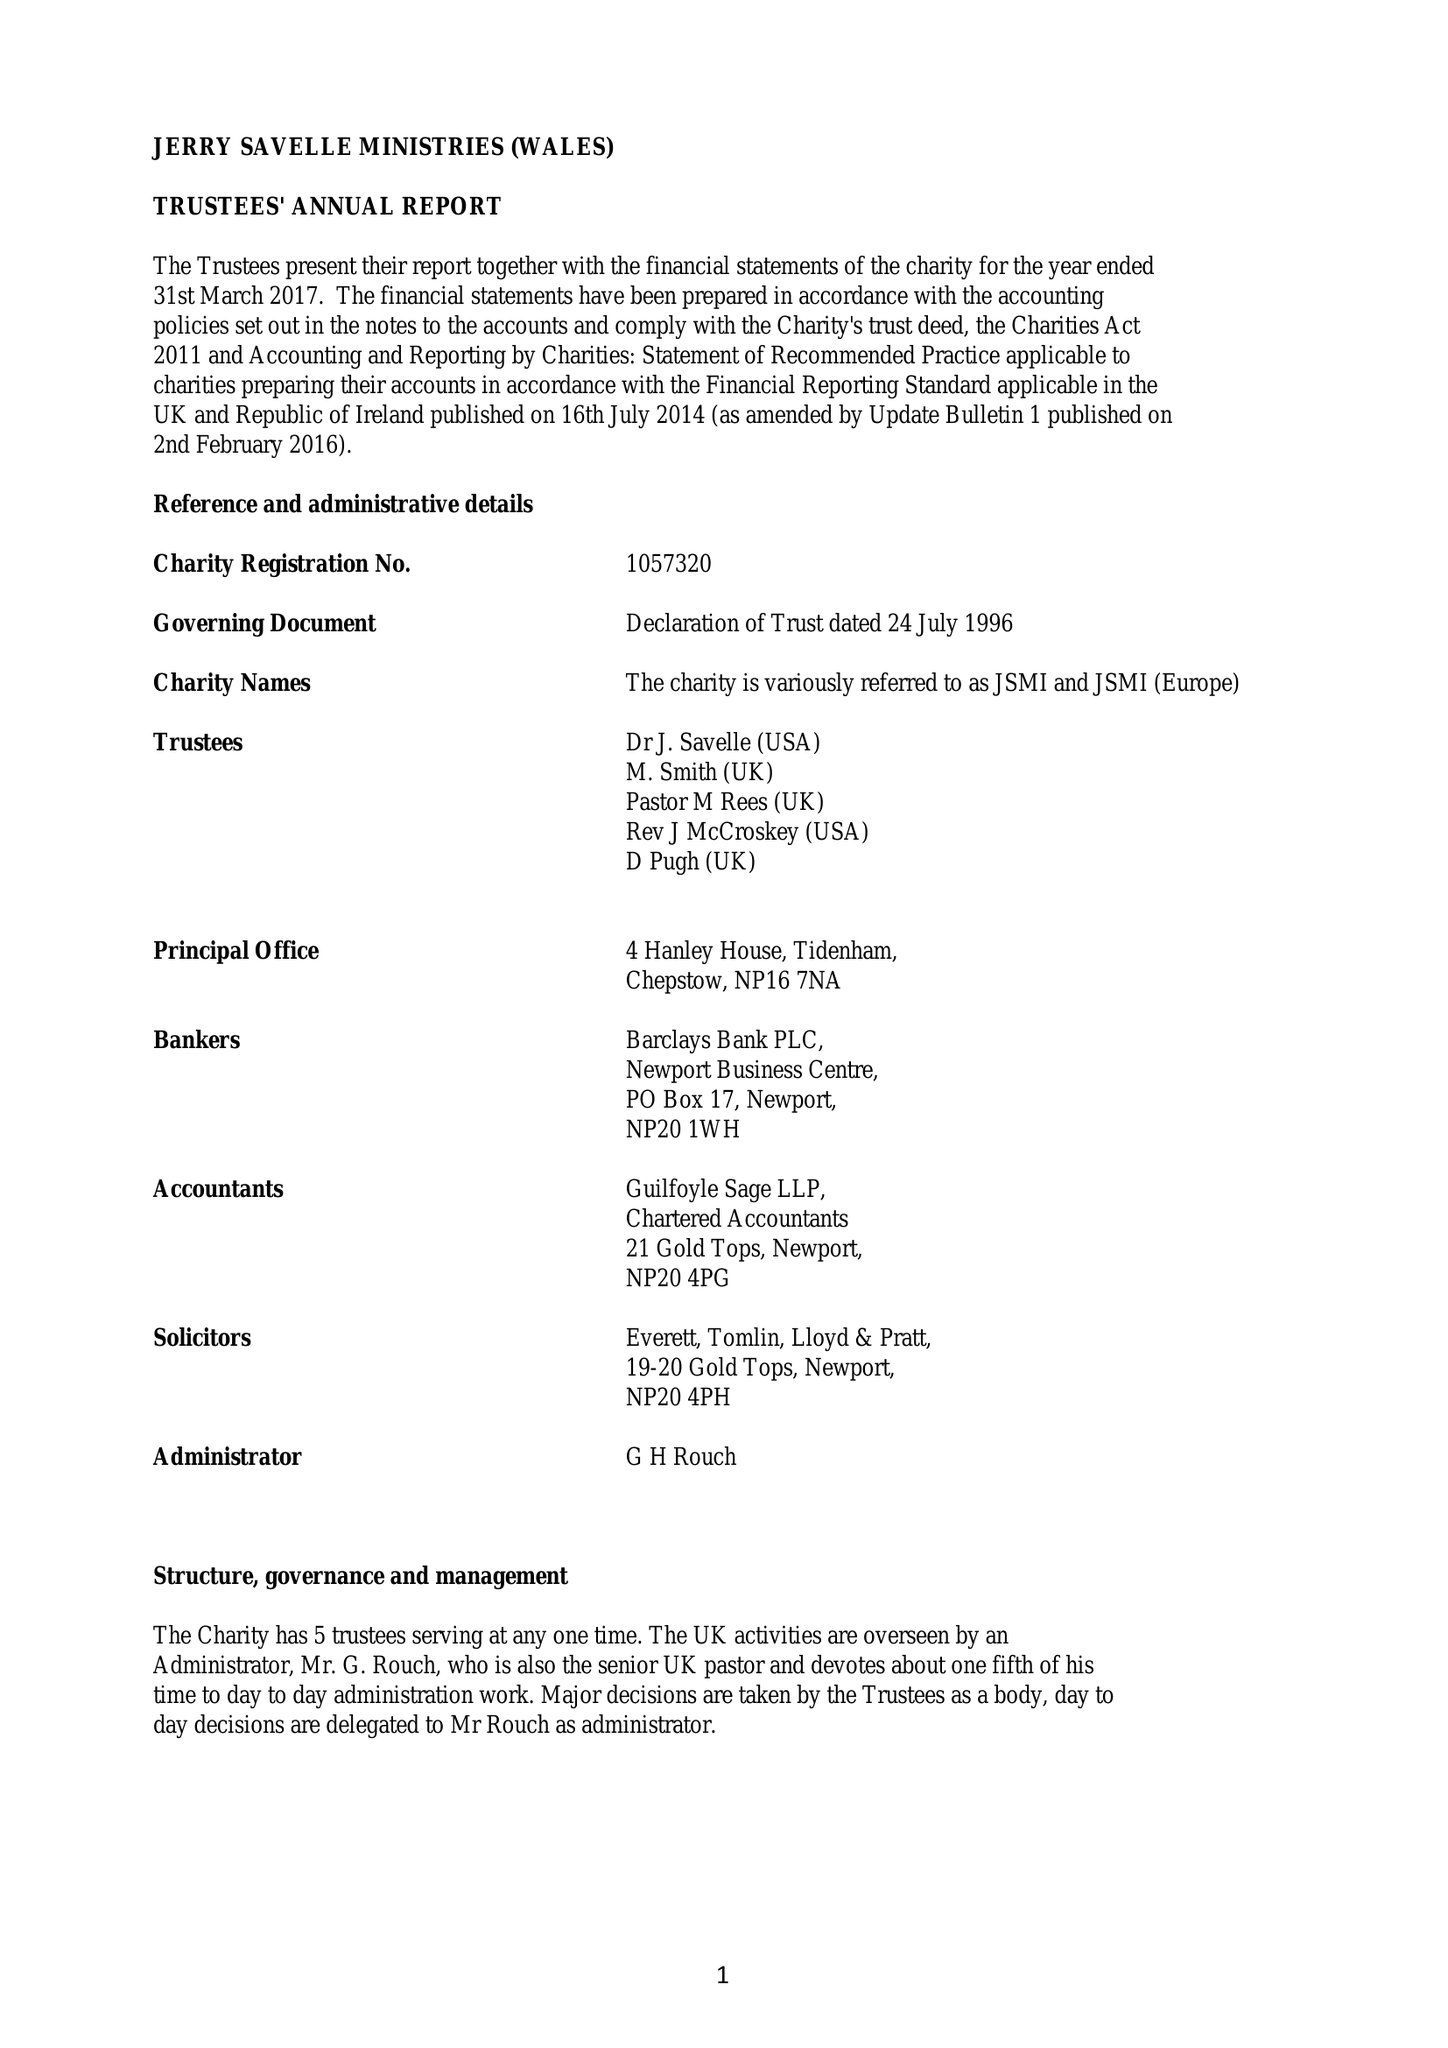What is the value for the address__street_line?
Answer the question using a single word or phrase. None 